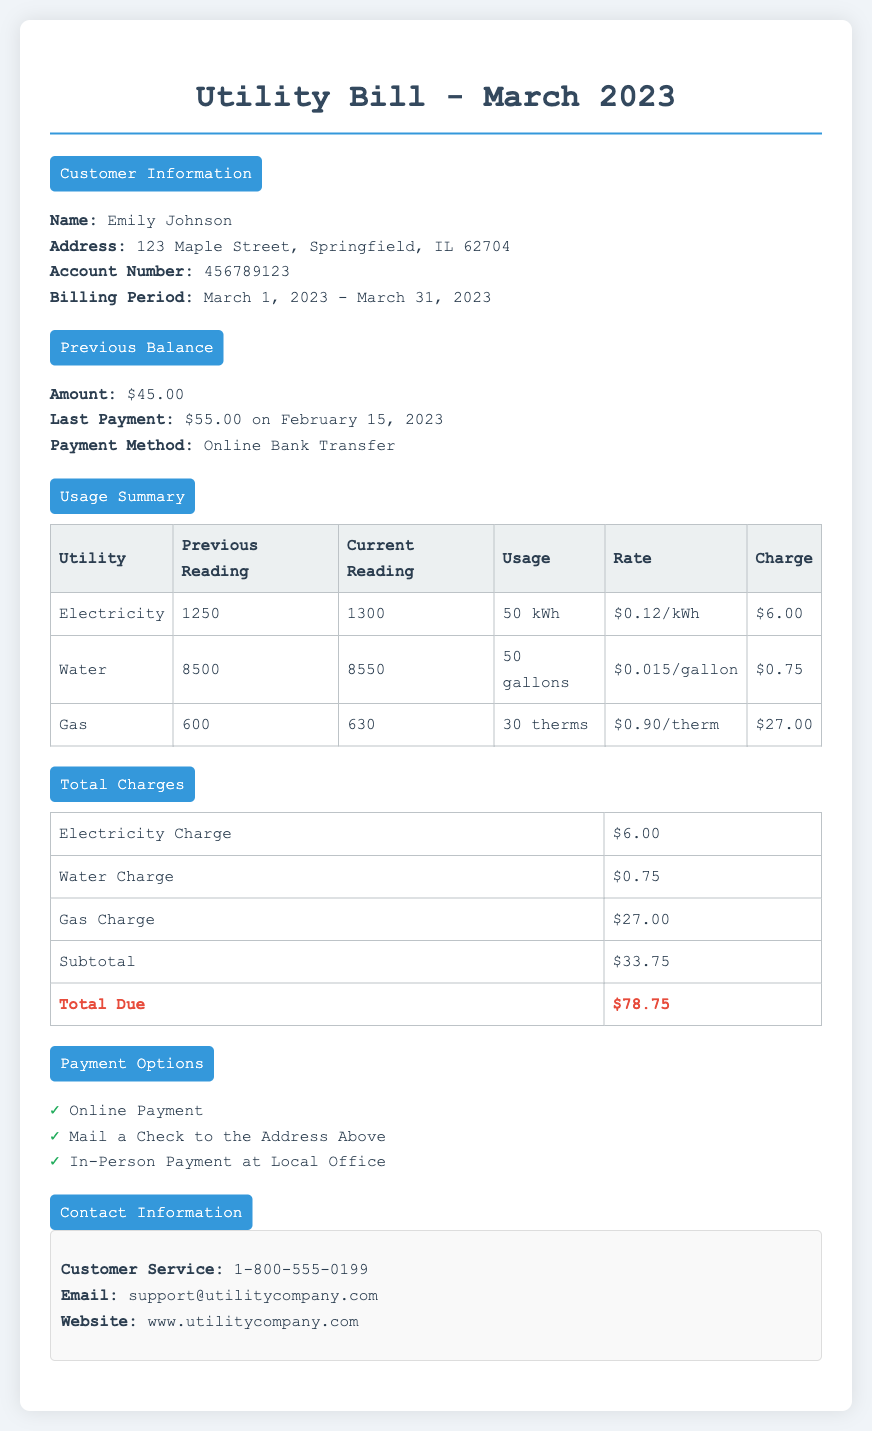What is the billing period for this utility bill? The billing period for the utility bill spans from March 1, 2023, to March 31, 2023.
Answer: March 1, 2023 - March 31, 2023 What was the last payment amount? The last payment made was $55.00.
Answer: $55.00 How much was the previous balance? The previous balance before the current bill is $45.00.
Answer: $45.00 What is the total charge for gas? The charge for gas based on usage is $27.00.
Answer: $27.00 What is the total amount due for this bill? The total amount due at the end of this bill is $78.75.
Answer: $78.75 How many gallons of water were used? The usage for water is reported as 50 gallons.
Answer: 50 gallons What contact number is provided for customer service? The customer service contact number listed is 1-800-555-0199.
Answer: 1-800-555-0199 What payment method was used for the last payment? The last payment method used was Online Bank Transfer.
Answer: Online Bank Transfer What is the previous reading for electricity? The previous reading for electricity was 1250.
Answer: 1250 